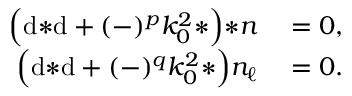Convert formula to latex. <formula><loc_0><loc_0><loc_500><loc_500>\begin{array} { r l } { \left ( d { * d } + ( - ) ^ { p } k _ { 0 } ^ { 2 } { * } \right ) { * n } } & = 0 , } \\ { \left ( d { * d } + ( - ) ^ { q } k _ { 0 } ^ { 2 } { * } \right ) n _ { \ell } } & = 0 . } \end{array}</formula> 